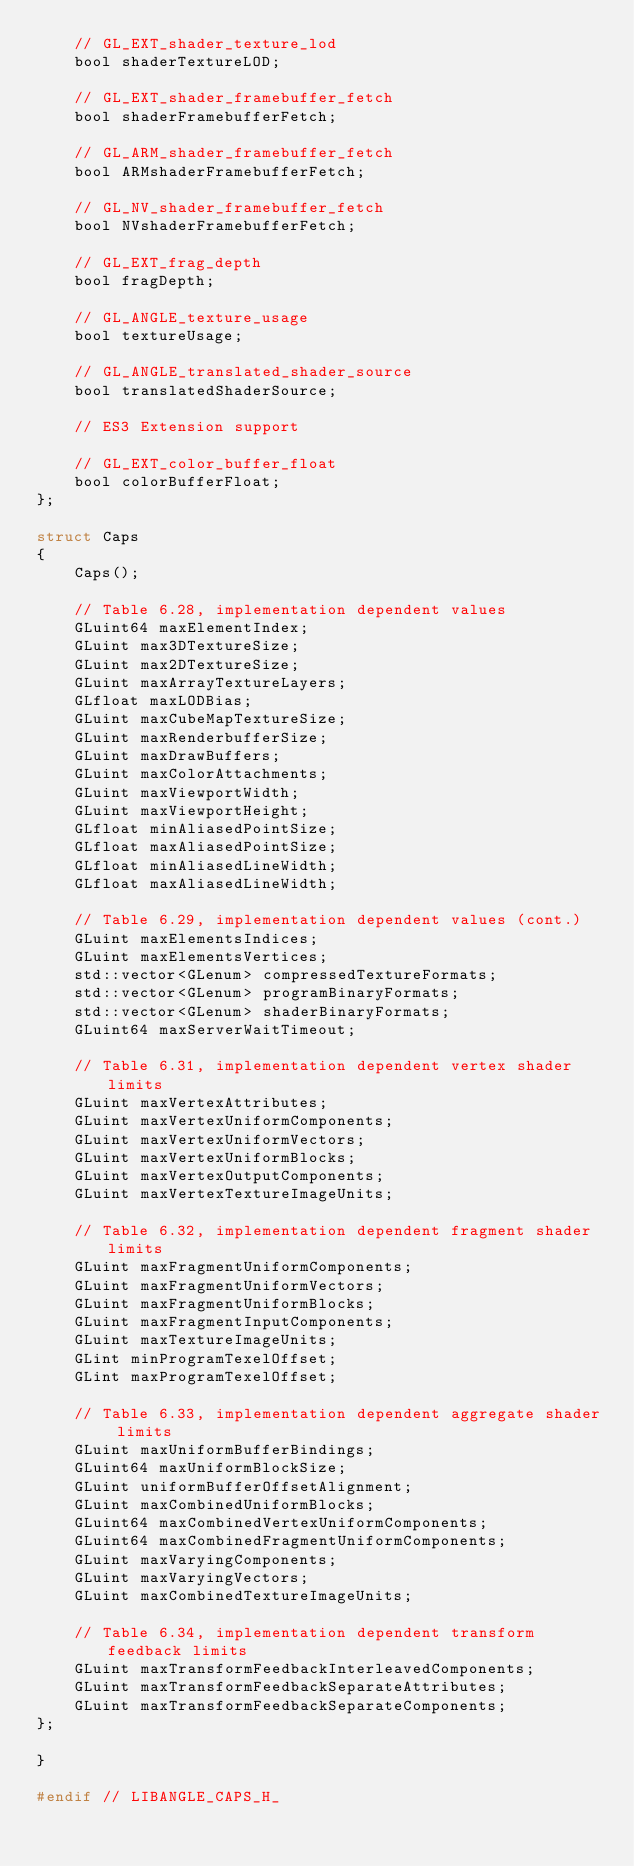Convert code to text. <code><loc_0><loc_0><loc_500><loc_500><_C_>    // GL_EXT_shader_texture_lod
    bool shaderTextureLOD;

    // GL_EXT_shader_framebuffer_fetch
    bool shaderFramebufferFetch;

    // GL_ARM_shader_framebuffer_fetch
    bool ARMshaderFramebufferFetch;

    // GL_NV_shader_framebuffer_fetch
    bool NVshaderFramebufferFetch;

    // GL_EXT_frag_depth
    bool fragDepth;

    // GL_ANGLE_texture_usage
    bool textureUsage;

    // GL_ANGLE_translated_shader_source
    bool translatedShaderSource;

    // ES3 Extension support

    // GL_EXT_color_buffer_float
    bool colorBufferFloat;
};

struct Caps
{
    Caps();

    // Table 6.28, implementation dependent values
    GLuint64 maxElementIndex;
    GLuint max3DTextureSize;
    GLuint max2DTextureSize;
    GLuint maxArrayTextureLayers;
    GLfloat maxLODBias;
    GLuint maxCubeMapTextureSize;
    GLuint maxRenderbufferSize;
    GLuint maxDrawBuffers;
    GLuint maxColorAttachments;
    GLuint maxViewportWidth;
    GLuint maxViewportHeight;
    GLfloat minAliasedPointSize;
    GLfloat maxAliasedPointSize;
    GLfloat minAliasedLineWidth;
    GLfloat maxAliasedLineWidth;

    // Table 6.29, implementation dependent values (cont.)
    GLuint maxElementsIndices;
    GLuint maxElementsVertices;
    std::vector<GLenum> compressedTextureFormats;
    std::vector<GLenum> programBinaryFormats;
    std::vector<GLenum> shaderBinaryFormats;
    GLuint64 maxServerWaitTimeout;

    // Table 6.31, implementation dependent vertex shader limits
    GLuint maxVertexAttributes;
    GLuint maxVertexUniformComponents;
    GLuint maxVertexUniformVectors;
    GLuint maxVertexUniformBlocks;
    GLuint maxVertexOutputComponents;
    GLuint maxVertexTextureImageUnits;

    // Table 6.32, implementation dependent fragment shader limits
    GLuint maxFragmentUniformComponents;
    GLuint maxFragmentUniformVectors;
    GLuint maxFragmentUniformBlocks;
    GLuint maxFragmentInputComponents;
    GLuint maxTextureImageUnits;
    GLint minProgramTexelOffset;
    GLint maxProgramTexelOffset;

    // Table 6.33, implementation dependent aggregate shader limits
    GLuint maxUniformBufferBindings;
    GLuint64 maxUniformBlockSize;
    GLuint uniformBufferOffsetAlignment;
    GLuint maxCombinedUniformBlocks;
    GLuint64 maxCombinedVertexUniformComponents;
    GLuint64 maxCombinedFragmentUniformComponents;
    GLuint maxVaryingComponents;
    GLuint maxVaryingVectors;
    GLuint maxCombinedTextureImageUnits;

    // Table 6.34, implementation dependent transform feedback limits
    GLuint maxTransformFeedbackInterleavedComponents;
    GLuint maxTransformFeedbackSeparateAttributes;
    GLuint maxTransformFeedbackSeparateComponents;
};

}

#endif // LIBANGLE_CAPS_H_
</code> 